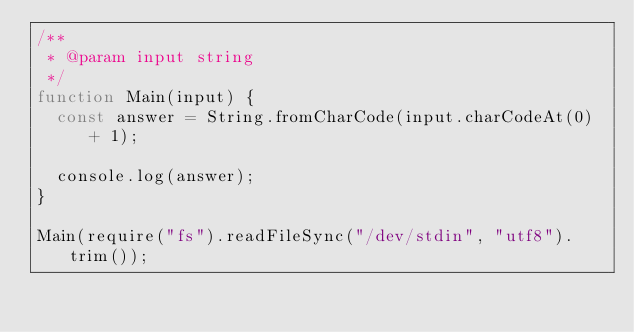Convert code to text. <code><loc_0><loc_0><loc_500><loc_500><_JavaScript_>/**
 * @param input string
 */
function Main(input) {
  const answer = String.fromCharCode(input.charCodeAt(0) + 1);

  console.log(answer);
}

Main(require("fs").readFileSync("/dev/stdin", "utf8").trim());
</code> 